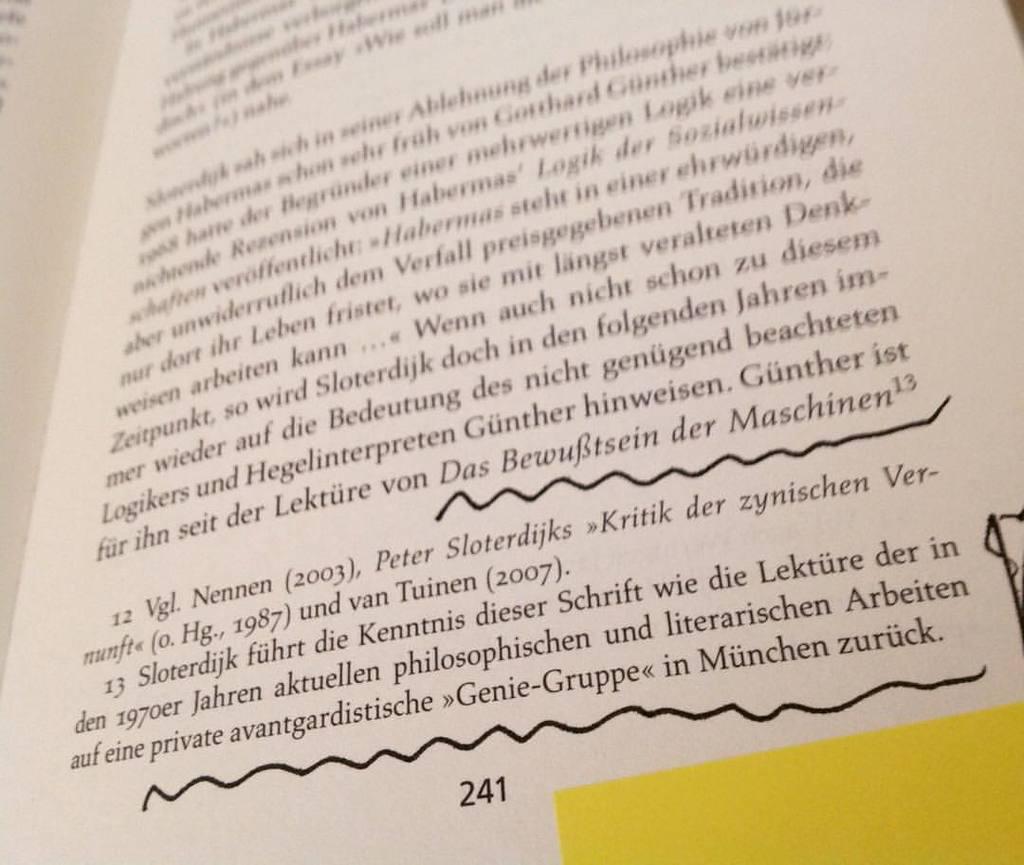What page number is this book turned to?
Offer a very short reply. 241. 